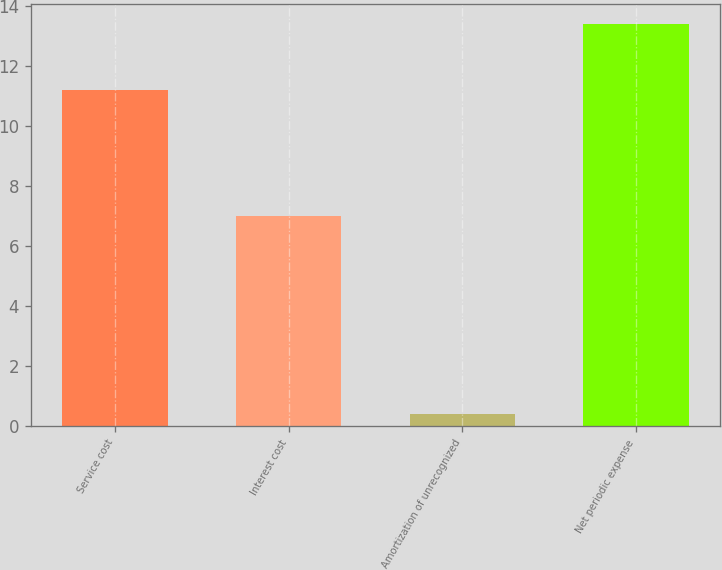Convert chart. <chart><loc_0><loc_0><loc_500><loc_500><bar_chart><fcel>Service cost<fcel>Interest cost<fcel>Amortization of unrecognized<fcel>Net periodic expense<nl><fcel>11.2<fcel>7<fcel>0.4<fcel>13.4<nl></chart> 